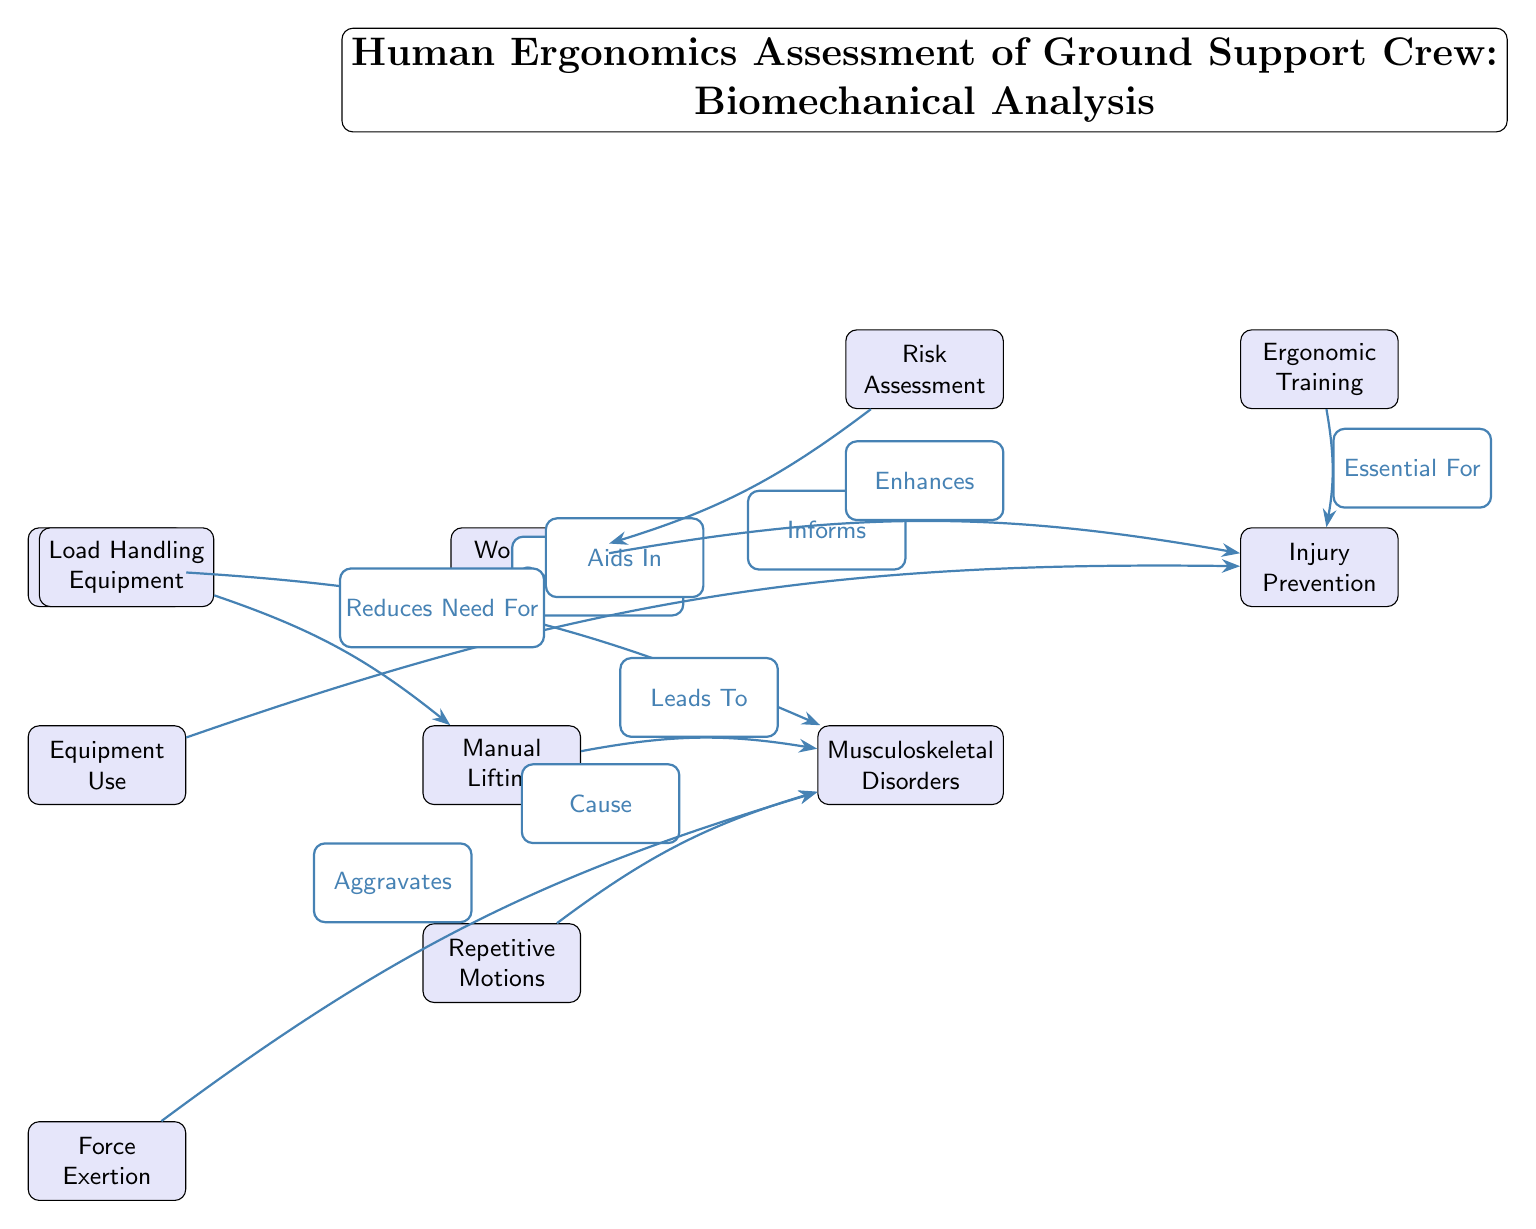What is the main title of the diagram? The title is located at the top of the diagram and summarizes the content, specifically mentioning "Human Ergonomics Assessment of Ground Support Crew: Biomechanical Analysis."
Answer: Human Ergonomics Assessment of Ground Support Crew: Biomechanical Analysis How many nodes are present in the diagram? By counting the number of distinct shapes or nodes in the diagram, there are a total of 11 nodes connected with edges.
Answer: 11 Which node contributes to musculoskeletal disorders? The edges connected to the node "musculoskeletal disorders" indicate contributions from several nodes, including "Worker Postures," "Manual Lifting," "Repetitive Motions," and "Force Exertion." The question requires one of these nodes, so any would suffice. Selecting "Worker Postures" as an example.
Answer: Worker Postures What role does "Equipment Use" play in relation to "Injury Prevention"? "Equipment Use" is connected to "Injury Prevention" with the edge label "Aids In," indicating a supportive role in preventing injuries. This shows a direct relationship between the two nodes.
Answer: Aids In Which node leads to musculoskeletal disorders? "Manual Lifting" is explicitly described as leading to musculoskeletal disorders in the diagram, shown with a directed edge from "Manual Lifting" to "Musculoskeletal Disorders."
Answer: Leads To What does "Ergonomic Training" contribute to in the diagram? The edge from "Ergonomic Training" shows that it is "Essential For" injury prevention, indicating that ergonomic training is pivotal for reducing the likelihood of injuries among ground support crew.
Answer: Essential For Which node reduces the need for "Manual Lifting"? The "Load Handling Equipment" node has an edge labeled "Reduces Need For" which indicates that it can lessen the necessity for manual lifting performed by the workers.
Answer: Reduces Need For What influences the "Workplace Design"? The diagram shows that "Risk Assessment" informs "Workplace Design," reflecting that understanding the risks is crucial for creating a safe and effective workplace layout.
Answer: Informs What do "Repetitive Motions" do in relation to "Musculoskeletal Disorders"? "Repetitive Motions" are connected to "Musculoskeletal Disorders" by an edge labeled "Cause," illustrating that repetitive actions can lead to health issues in the musculoskeletal system.
Answer: Cause 